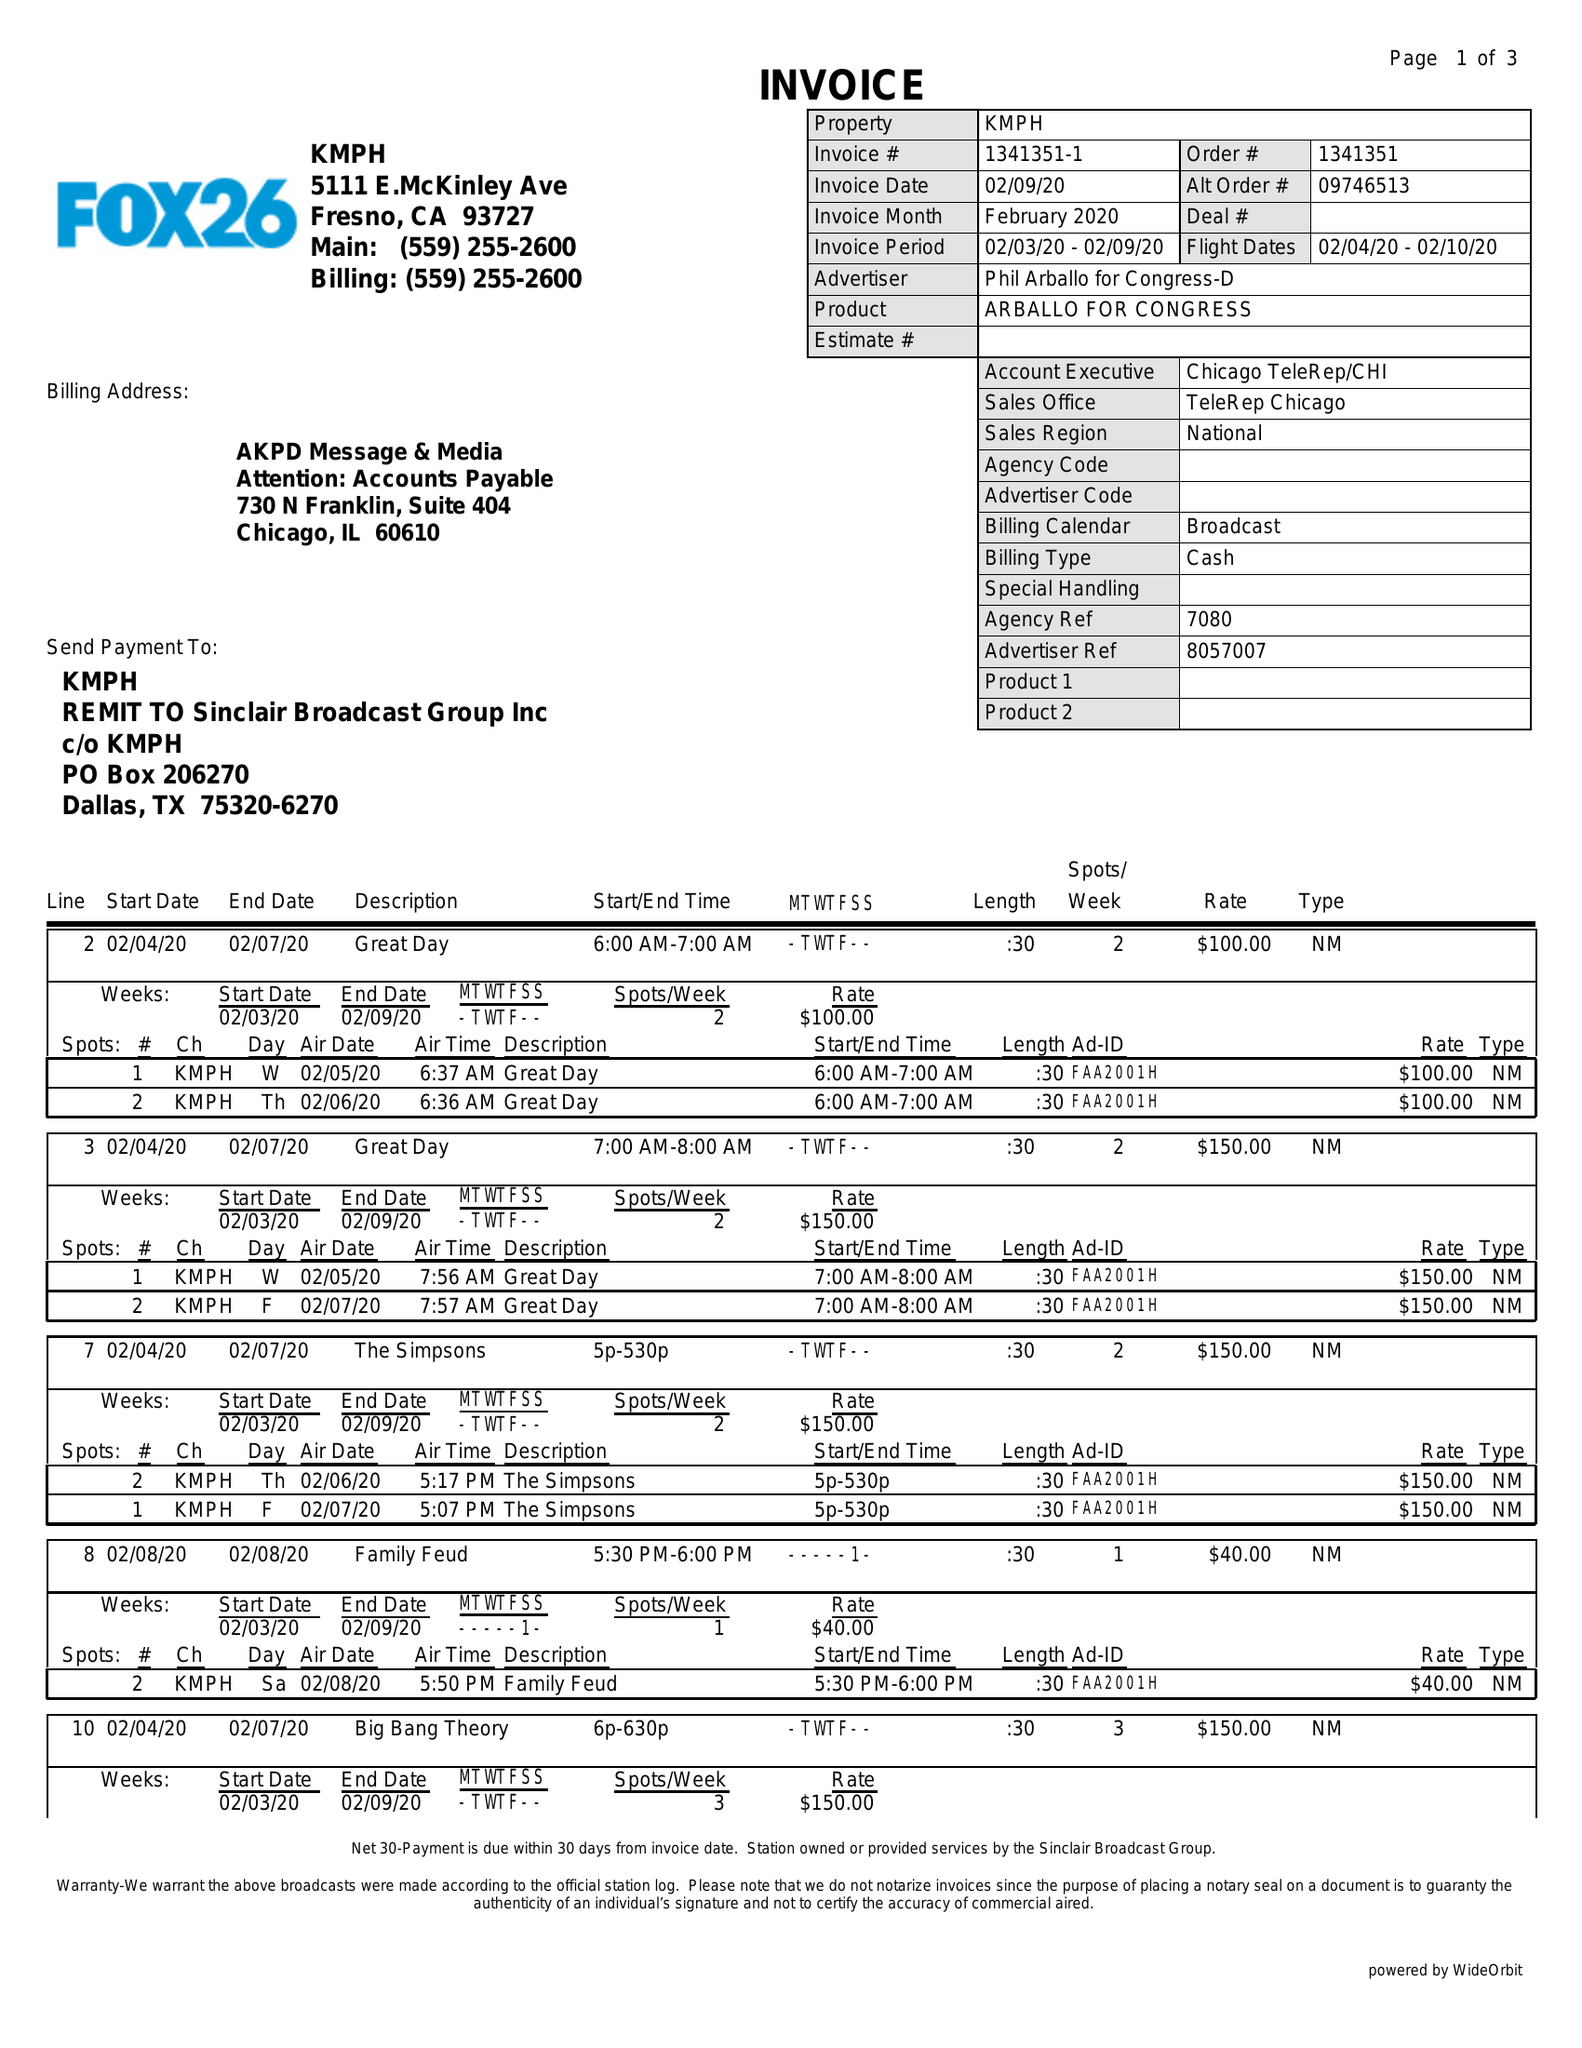What is the value for the contract_num?
Answer the question using a single word or phrase. 1341351 